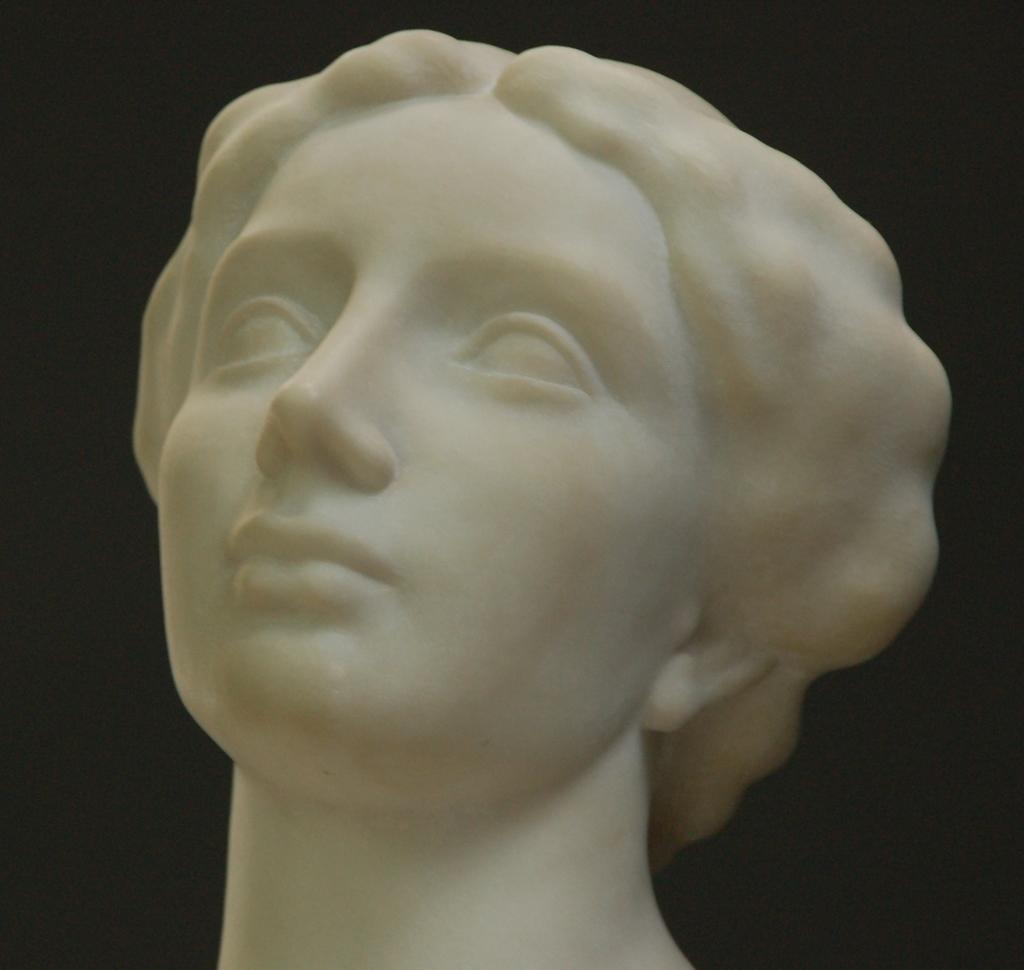What is the main subject of the image? There is a statue in the image. What is the color of the statue? The statue is white in color. What can be observed about the background of the image? The background of the image is dark. Can you tell me how many kittens are playing with a record in the image? There are no kittens or records present in the image; it features a white statue with a dark background. What type of mine is depicted in the image? There is no mine present in the image; it features a white statue with a dark background. 